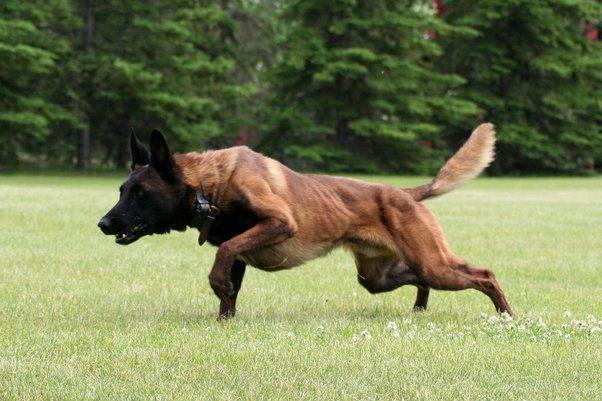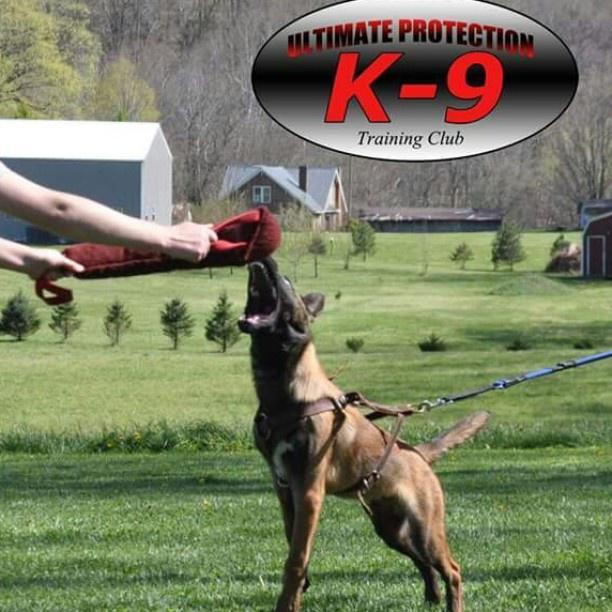The first image is the image on the left, the second image is the image on the right. For the images displayed, is the sentence "One of the images contains more than one dog." factually correct? Answer yes or no. No. The first image is the image on the left, the second image is the image on the right. Analyze the images presented: Is the assertion "An image shows an arm extending something to a german shepherd on a leash." valid? Answer yes or no. Yes. 